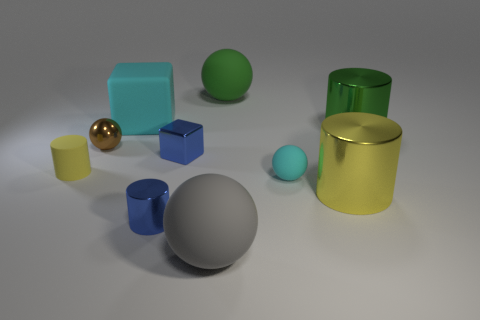What time of day does the lighting in this scene suggest? The soft shadows and even lighting in the scene suggest it is a controlled indoor environment, rather than a specific time of day. The lighting is likely artificial, designed to resemble diffuse daylight conditions typically seen on an overcast day or in a photography studio. 